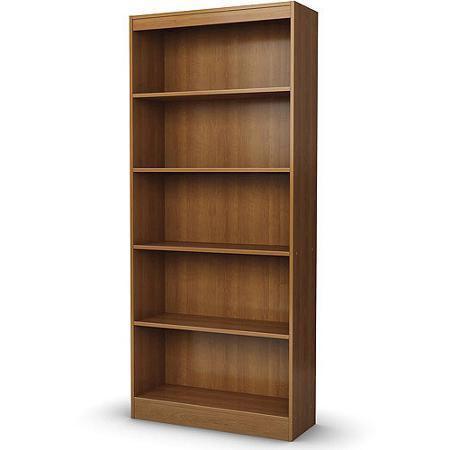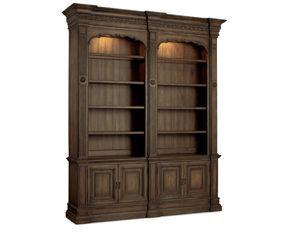The first image is the image on the left, the second image is the image on the right. Assess this claim about the two images: "There are exactly two empty bookcases.". Correct or not? Answer yes or no. Yes. The first image is the image on the left, the second image is the image on the right. Given the left and right images, does the statement "One brown bookcase has a grid of same-size square compartments, and the other brown bookcase has closed-front storage at the bottom." hold true? Answer yes or no. No. 